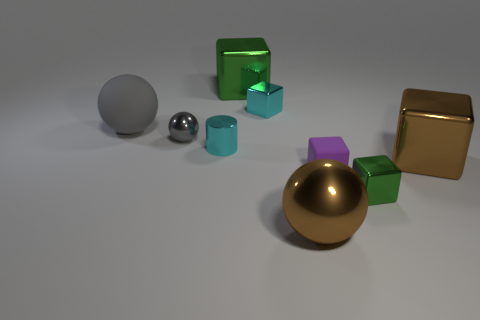Can you describe the colors and materials of the objects? Certainly! In the image, there are objects with a variety of colors and materials. There are two rubber spheres, one gray and one smaller metallic silver. The transparent blocks seem to be made of glass, with one larger in green and a smaller one in a lighter shade of green or cyan. The solid blocks appear metallic, with a large one in gold and a smaller one in purple. The play of light on the surfaces hints at their differing textures and materials. 